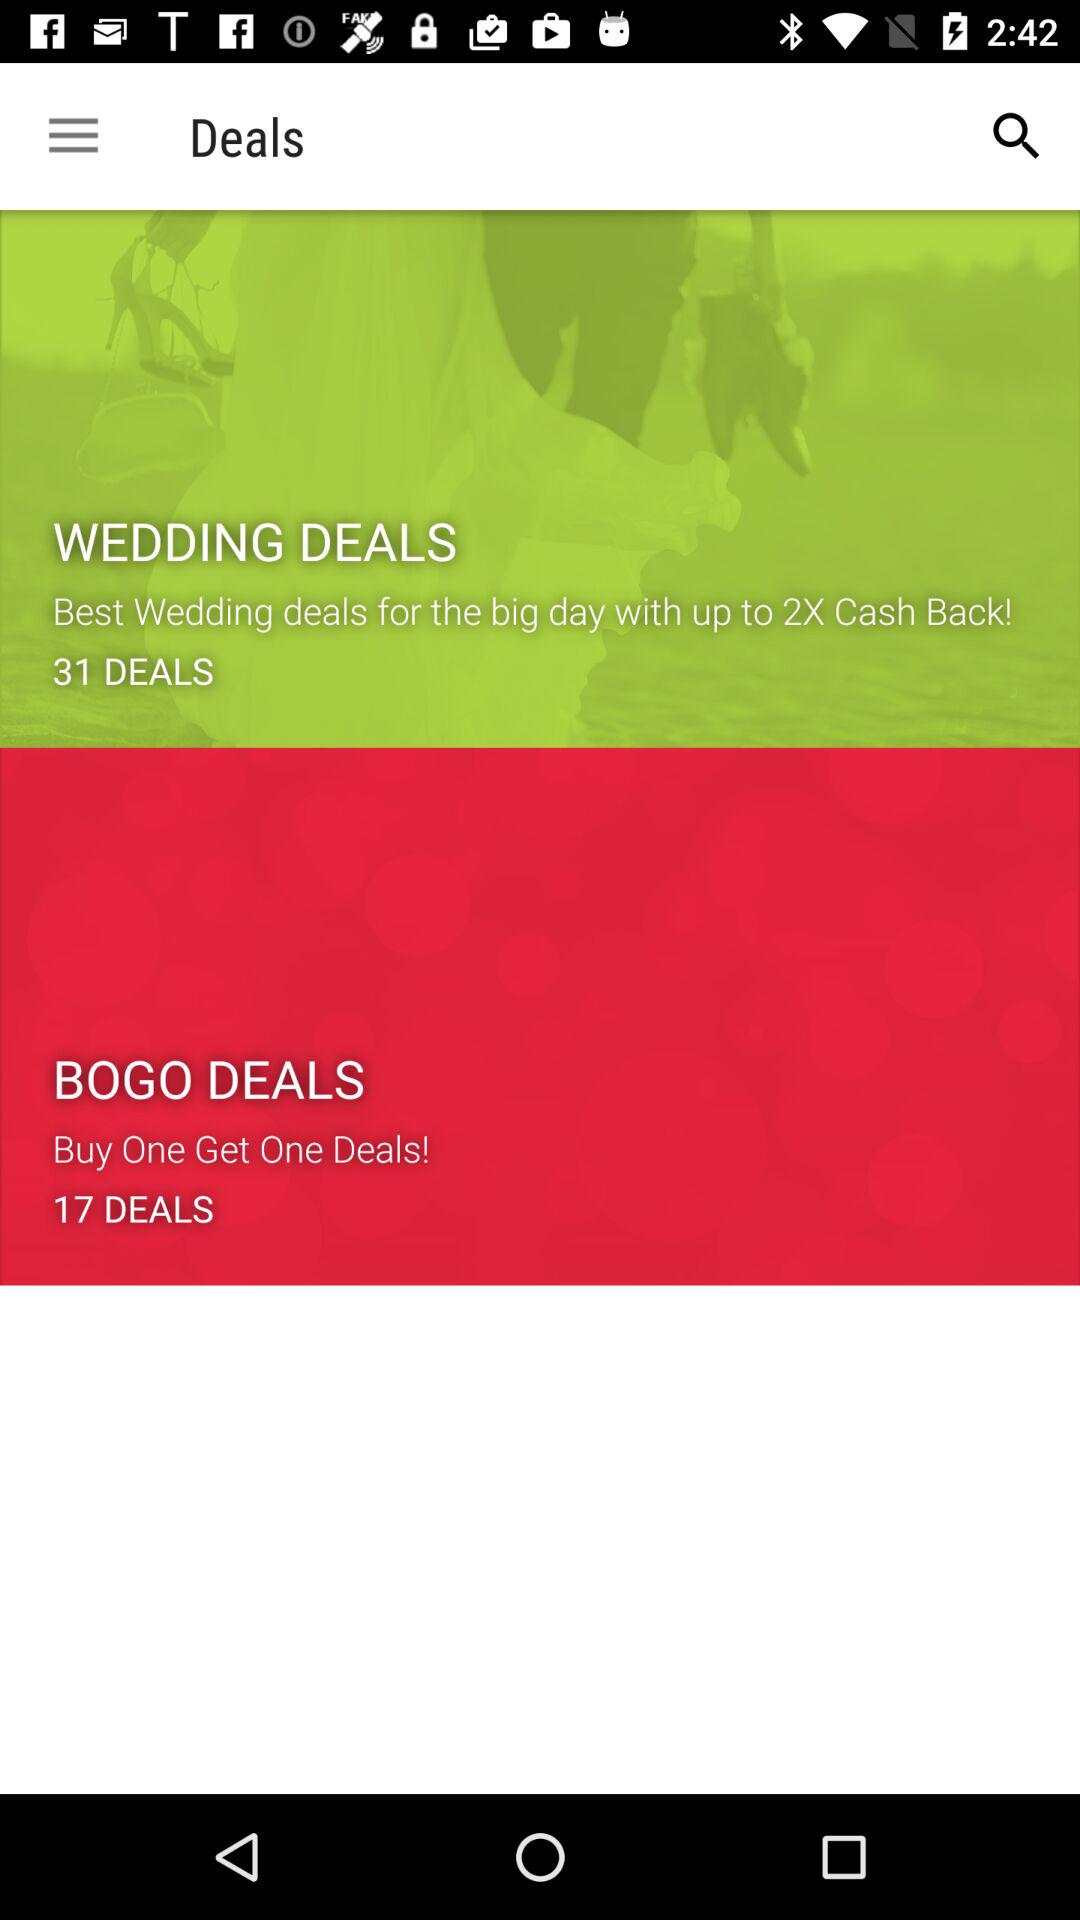How much cashback is offered on the best wedding deals for the big day? The cashback that is offered is up to 2X. 